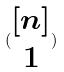<formula> <loc_0><loc_0><loc_500><loc_500>( \begin{matrix} [ n ] \\ 1 \end{matrix} )</formula> 